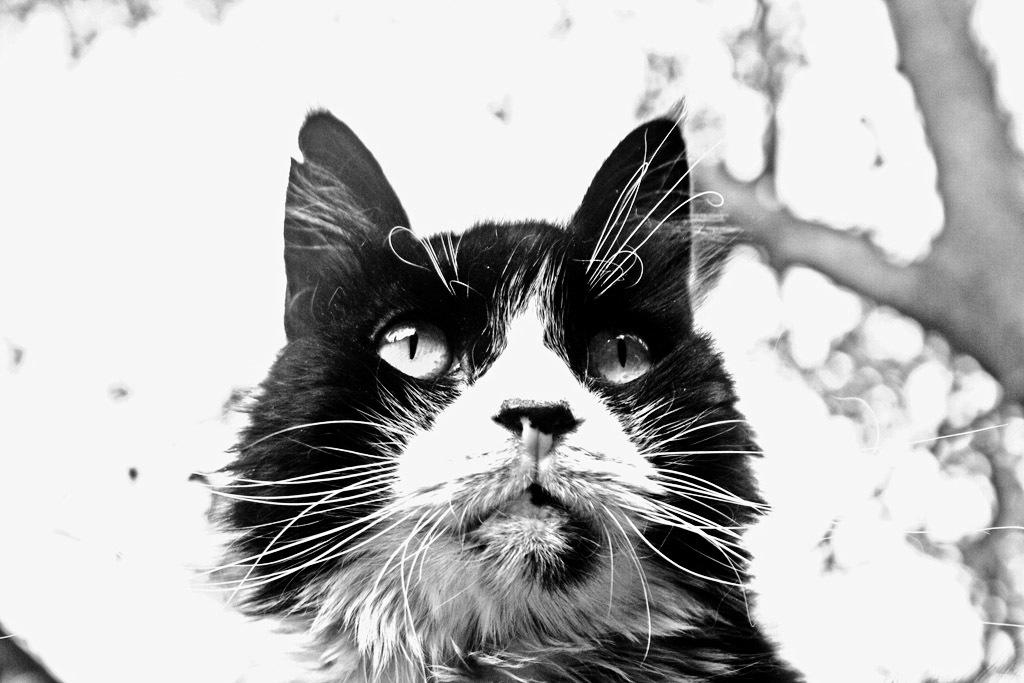What type of animal is in the image? There is a black color cat in the image. Can you describe the background of the image? The background of the image is blurry. What type of note is the cat holding in the image? There is no note present in the image; it only features a black color cat. How many dogs are visible in the image? There are no dogs present in the image; it only features a black color cat. 